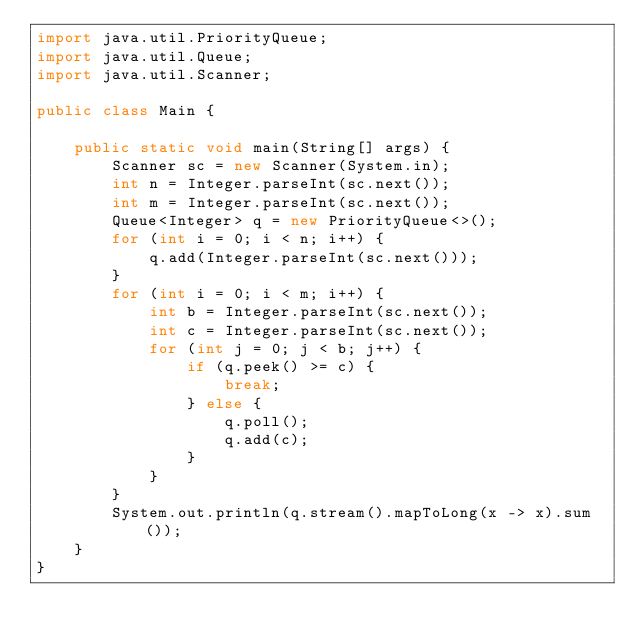<code> <loc_0><loc_0><loc_500><loc_500><_Java_>import java.util.PriorityQueue;
import java.util.Queue;
import java.util.Scanner;

public class Main {

    public static void main(String[] args) {
        Scanner sc = new Scanner(System.in);
        int n = Integer.parseInt(sc.next());
        int m = Integer.parseInt(sc.next());
        Queue<Integer> q = new PriorityQueue<>();
        for (int i = 0; i < n; i++) {
            q.add(Integer.parseInt(sc.next()));
        }
        for (int i = 0; i < m; i++) {
            int b = Integer.parseInt(sc.next());
            int c = Integer.parseInt(sc.next());
            for (int j = 0; j < b; j++) {
                if (q.peek() >= c) {
                    break;
                } else {
                    q.poll();
                    q.add(c);
                }
            }
        }
        System.out.println(q.stream().mapToLong(x -> x).sum());
    }
}</code> 